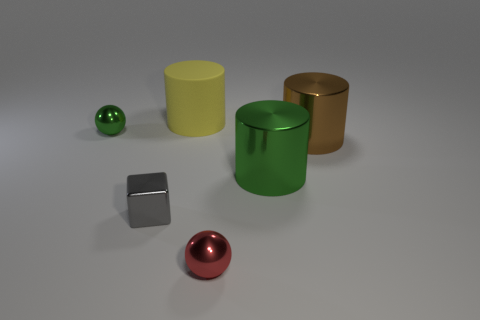Add 3 large matte cubes. How many objects exist? 9 Subtract all cubes. How many objects are left? 5 Add 3 tiny blue rubber cylinders. How many tiny blue rubber cylinders exist? 3 Subtract 1 green cylinders. How many objects are left? 5 Subtract all large metallic things. Subtract all cylinders. How many objects are left? 1 Add 2 small shiny cubes. How many small shiny cubes are left? 3 